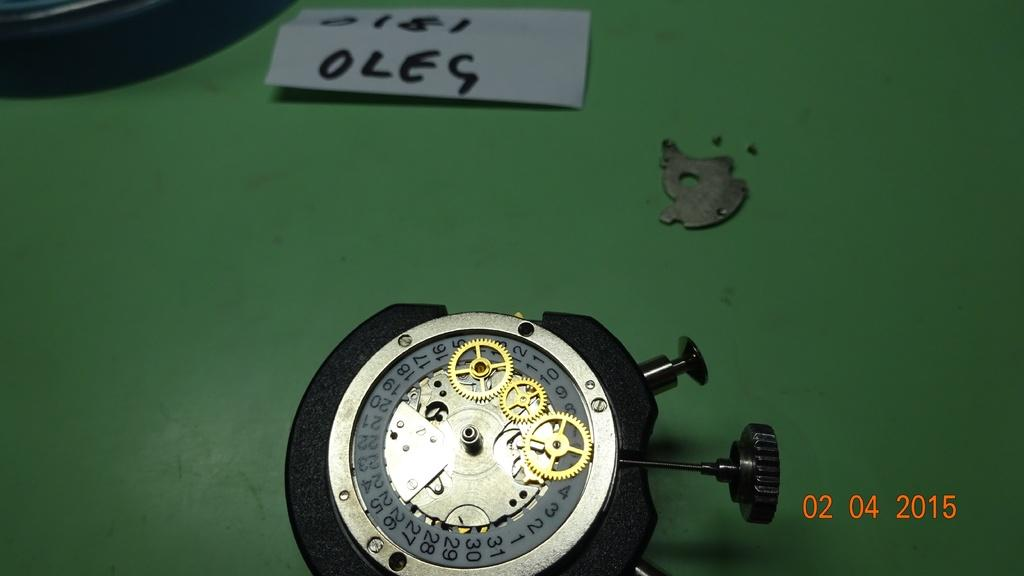Provide a one-sentence caption for the provided image. A timer and piece of paper that reads OLEG. 